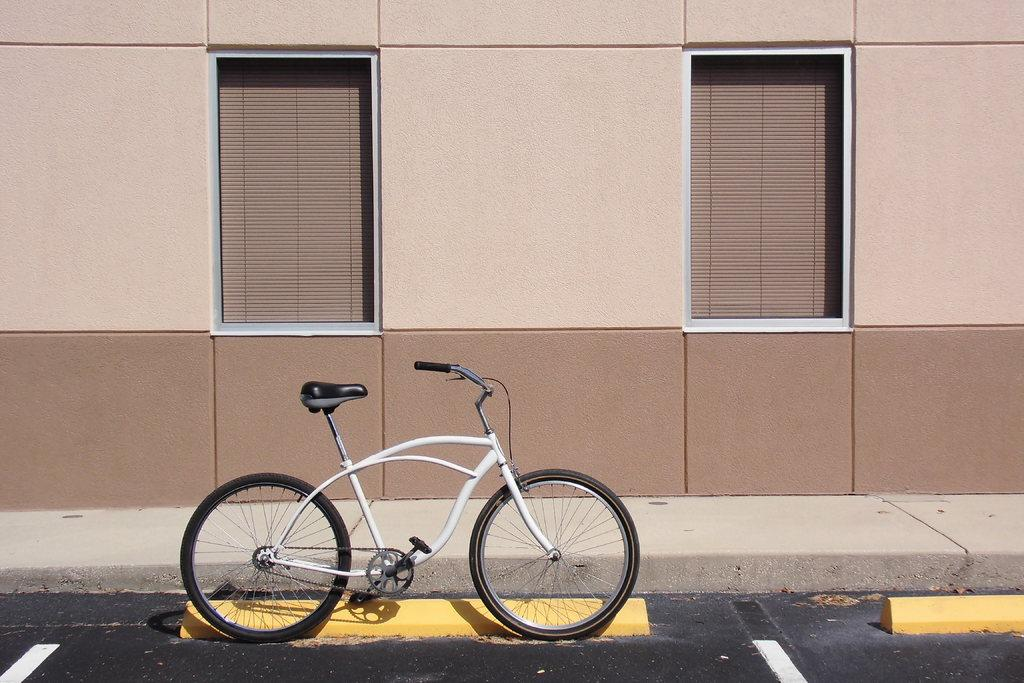What is the main subject of the picture? The main subject of the picture is a bicycle. Can you describe the color of the bicycle? The bicycle is white in color. What other object can be seen beside the bicycle? There is a yellow object beside the bicycle. What type of structure is visible in the picture? There is a building in the picture. How many windows are present on the building? The building has two windows. Reasoning: Let'ing: Let's think step by step in order to produce the conversation. We start by identifying the main subject of the image, which is the bicycle. Next, we describe the color of the bicycle, which is white. Then, we mention the yellow object beside the bicycle, providing additional information about the image. We also describe the building in the picture and the number of windows it has. Absurd Question/Answer: What type of leather is used to make the soap in the image? There is no soap or leather present in the image; it features a white bicycle and a yellow object beside it, along with a building in the background. What type of steel is used to make the soap in the image? There is no soap or steel present in the image; it features a white bicycle and a yellow object beside it, along with a building in the background. 